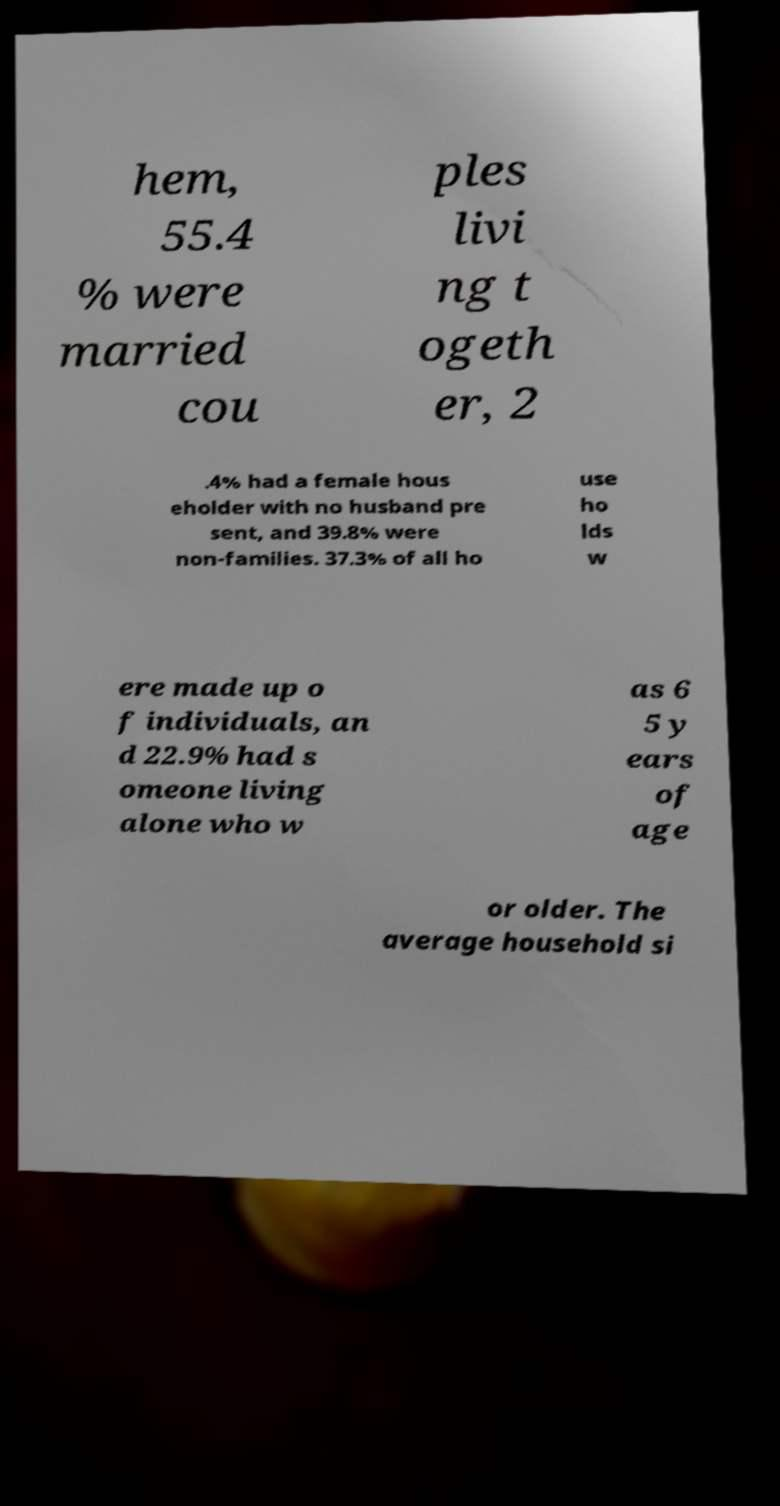Please read and relay the text visible in this image. What does it say? hem, 55.4 % were married cou ples livi ng t ogeth er, 2 .4% had a female hous eholder with no husband pre sent, and 39.8% were non-families. 37.3% of all ho use ho lds w ere made up o f individuals, an d 22.9% had s omeone living alone who w as 6 5 y ears of age or older. The average household si 